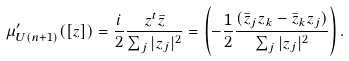Convert formula to latex. <formula><loc_0><loc_0><loc_500><loc_500>\mu ^ { \prime } _ { U ( n + 1 ) } ( [ z ] ) = \frac { i } { 2 } \frac { z ^ { t } \bar { z } } { \sum _ { j } | z _ { j } | ^ { 2 } } = \left ( - \frac { 1 } { 2 } \frac { ( \bar { z } _ { j } z _ { k } - \bar { z } _ { k } z _ { j } ) } { \sum _ { j } | z _ { j } | ^ { 2 } } \right ) .</formula> 